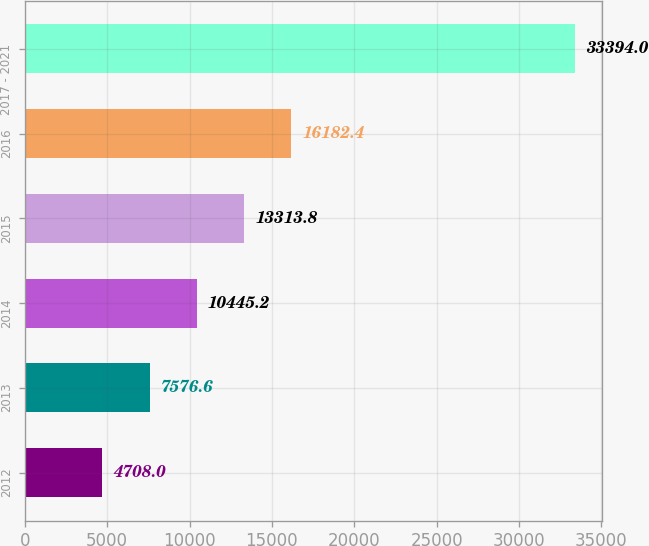Convert chart. <chart><loc_0><loc_0><loc_500><loc_500><bar_chart><fcel>2012<fcel>2013<fcel>2014<fcel>2015<fcel>2016<fcel>2017 - 2021<nl><fcel>4708<fcel>7576.6<fcel>10445.2<fcel>13313.8<fcel>16182.4<fcel>33394<nl></chart> 